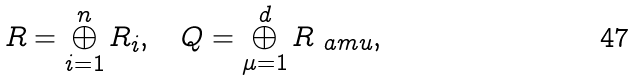<formula> <loc_0><loc_0><loc_500><loc_500>R = \bigoplus _ { i = 1 } ^ { n } R _ { i } , \quad Q = \bigoplus _ { \mu = 1 } ^ { d } R _ { \ a m u } ,</formula> 